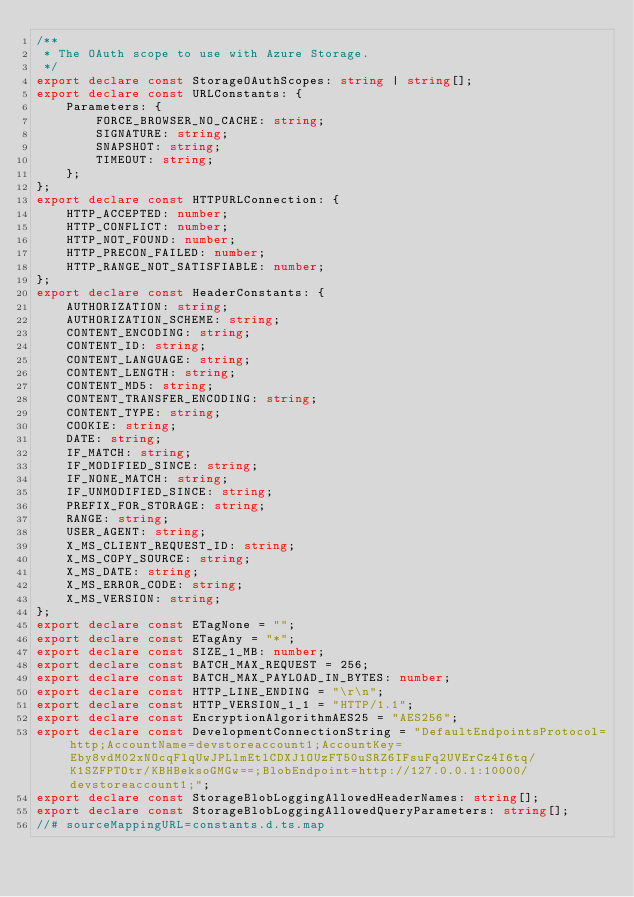Convert code to text. <code><loc_0><loc_0><loc_500><loc_500><_TypeScript_>/**
 * The OAuth scope to use with Azure Storage.
 */
export declare const StorageOAuthScopes: string | string[];
export declare const URLConstants: {
    Parameters: {
        FORCE_BROWSER_NO_CACHE: string;
        SIGNATURE: string;
        SNAPSHOT: string;
        TIMEOUT: string;
    };
};
export declare const HTTPURLConnection: {
    HTTP_ACCEPTED: number;
    HTTP_CONFLICT: number;
    HTTP_NOT_FOUND: number;
    HTTP_PRECON_FAILED: number;
    HTTP_RANGE_NOT_SATISFIABLE: number;
};
export declare const HeaderConstants: {
    AUTHORIZATION: string;
    AUTHORIZATION_SCHEME: string;
    CONTENT_ENCODING: string;
    CONTENT_ID: string;
    CONTENT_LANGUAGE: string;
    CONTENT_LENGTH: string;
    CONTENT_MD5: string;
    CONTENT_TRANSFER_ENCODING: string;
    CONTENT_TYPE: string;
    COOKIE: string;
    DATE: string;
    IF_MATCH: string;
    IF_MODIFIED_SINCE: string;
    IF_NONE_MATCH: string;
    IF_UNMODIFIED_SINCE: string;
    PREFIX_FOR_STORAGE: string;
    RANGE: string;
    USER_AGENT: string;
    X_MS_CLIENT_REQUEST_ID: string;
    X_MS_COPY_SOURCE: string;
    X_MS_DATE: string;
    X_MS_ERROR_CODE: string;
    X_MS_VERSION: string;
};
export declare const ETagNone = "";
export declare const ETagAny = "*";
export declare const SIZE_1_MB: number;
export declare const BATCH_MAX_REQUEST = 256;
export declare const BATCH_MAX_PAYLOAD_IN_BYTES: number;
export declare const HTTP_LINE_ENDING = "\r\n";
export declare const HTTP_VERSION_1_1 = "HTTP/1.1";
export declare const EncryptionAlgorithmAES25 = "AES256";
export declare const DevelopmentConnectionString = "DefaultEndpointsProtocol=http;AccountName=devstoreaccount1;AccountKey=Eby8vdM02xNOcqFlqUwJPLlmEtlCDXJ1OUzFT50uSRZ6IFsuFq2UVErCz4I6tq/K1SZFPTOtr/KBHBeksoGMGw==;BlobEndpoint=http://127.0.0.1:10000/devstoreaccount1;";
export declare const StorageBlobLoggingAllowedHeaderNames: string[];
export declare const StorageBlobLoggingAllowedQueryParameters: string[];
//# sourceMappingURL=constants.d.ts.map
</code> 